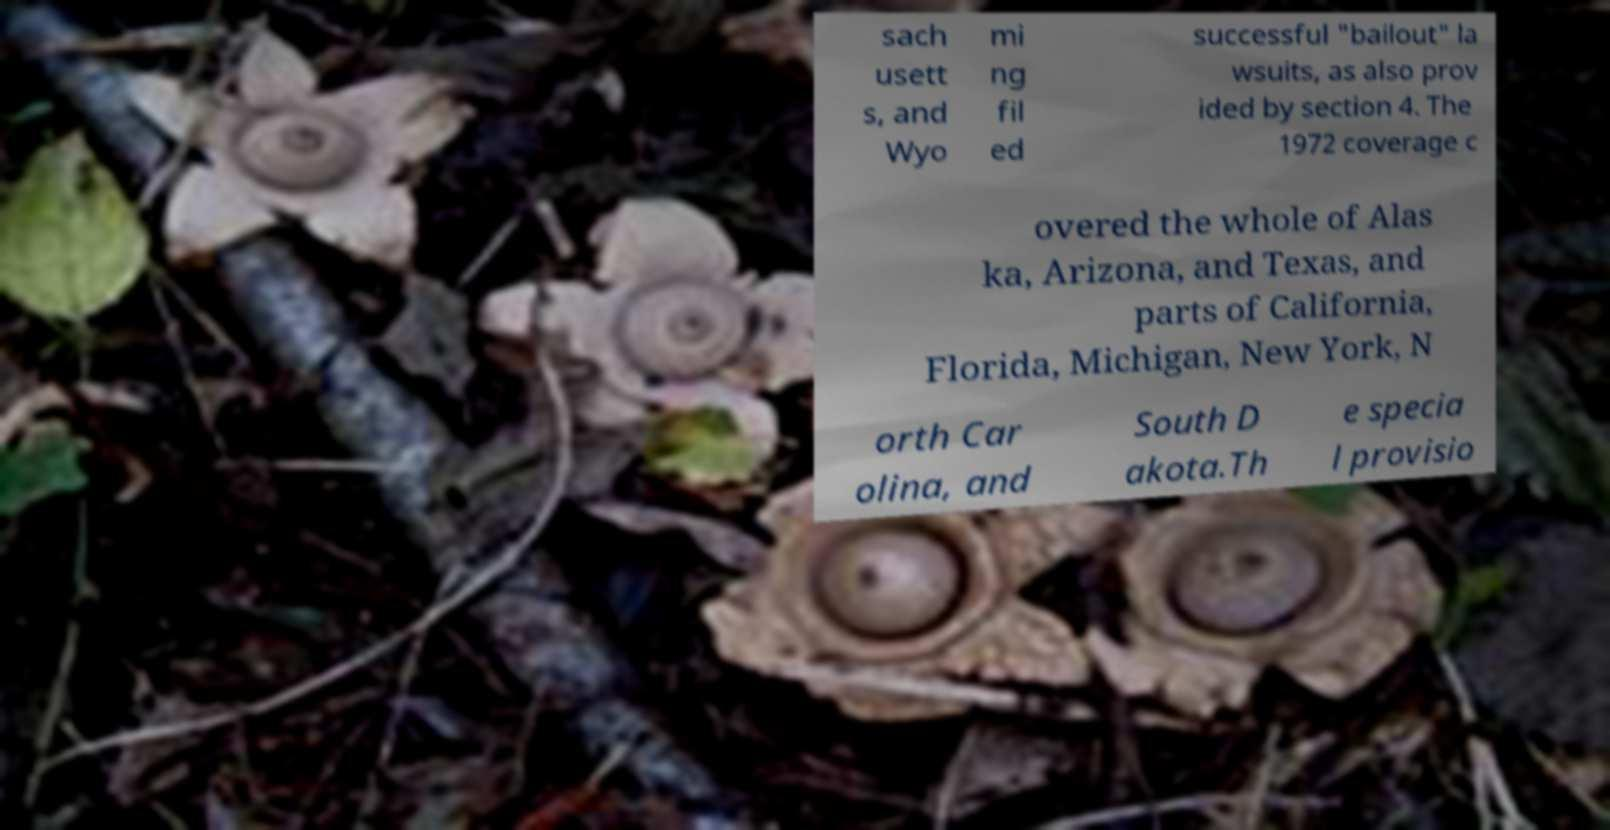I need the written content from this picture converted into text. Can you do that? sach usett s, and Wyo mi ng fil ed successful "bailout" la wsuits, as also prov ided by section 4. The 1972 coverage c overed the whole of Alas ka, Arizona, and Texas, and parts of California, Florida, Michigan, New York, N orth Car olina, and South D akota.Th e specia l provisio 